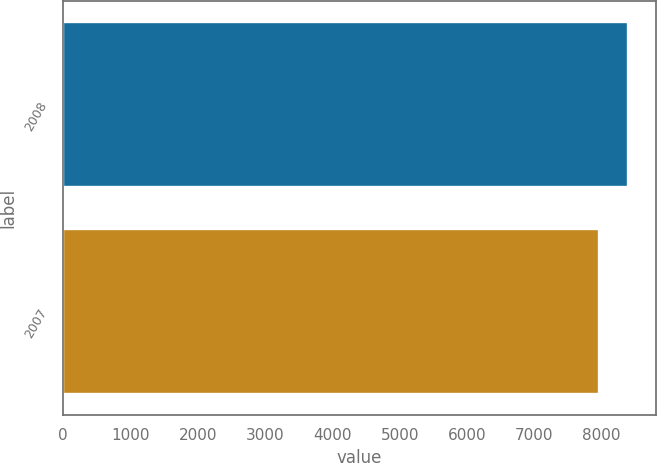Convert chart. <chart><loc_0><loc_0><loc_500><loc_500><bar_chart><fcel>2008<fcel>2007<nl><fcel>8388<fcel>7967<nl></chart> 